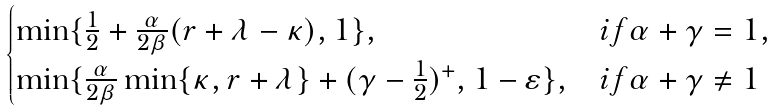Convert formula to latex. <formula><loc_0><loc_0><loc_500><loc_500>\begin{cases} \min \{ \frac { 1 } { 2 } + \frac { \alpha } { 2 \beta } ( r + \lambda - \kappa ) , 1 \} , & i f \alpha + \gamma = 1 , \\ \min \{ \frac { \alpha } { 2 \beta } \min \{ \kappa , r + \lambda \} + ( \gamma - \frac { 1 } { 2 } ) ^ { + } , 1 - \varepsilon \} , & i f \alpha + \gamma \neq 1 \end{cases}</formula> 